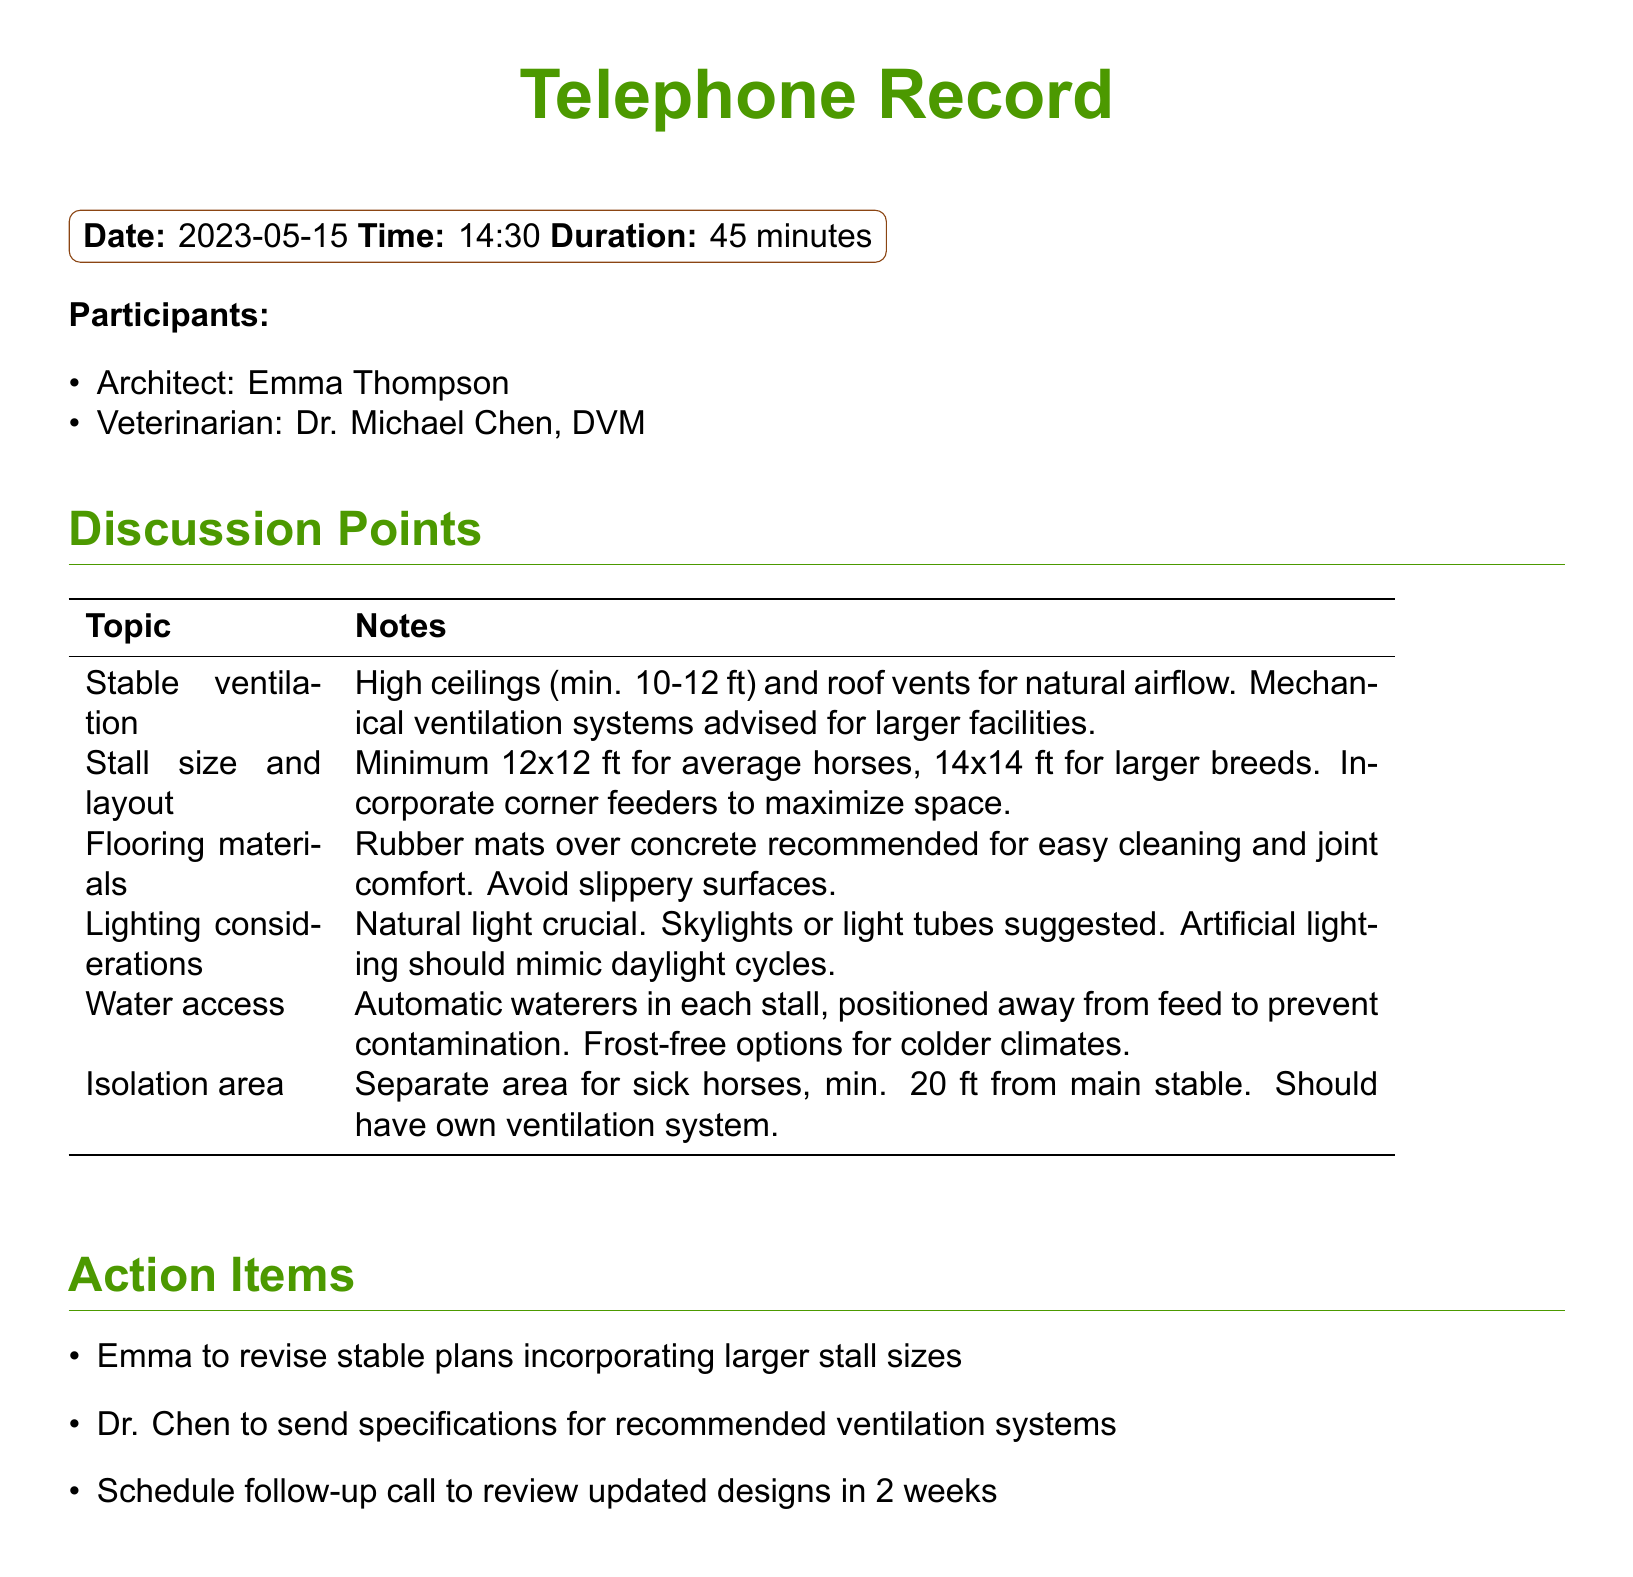What is the date of the telephone record? The date is clearly stated in the header of the document.
Answer: 2023-05-15 Who participated in the call? The participants are listed in the 'Participants' section of the document.
Answer: Emma Thompson and Dr. Michael Chen What is the recommended minimum stall size for average horses? The information is found in the discussion points table regarding stall size and layout.
Answer: 12x12 ft What is one flooring material recommended for horse stables? The flooring materials section provides specific recommendations relevant to cleaning and comfort.
Answer: Rubber mats How far should the isolation area for sick horses be from the main stable? This information is specifically mentioned under the isolation area discussion point.
Answer: 20 ft What is one action item for Emma? Action items are listed at the end of the document outlining tasks for each participant.
Answer: Revise stable plans incorporating larger stall sizes When is the follow-up call scheduled? The follow-up call mention is included in the action items section.
Answer: In 2 weeks 